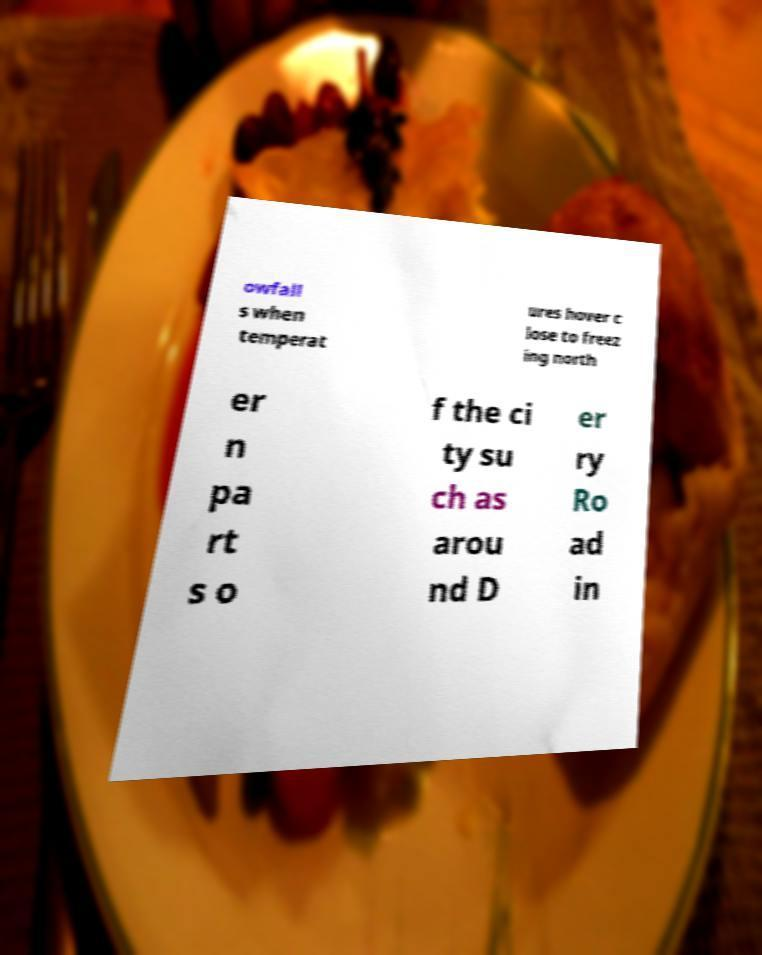Can you accurately transcribe the text from the provided image for me? owfall s when temperat ures hover c lose to freez ing north er n pa rt s o f the ci ty su ch as arou nd D er ry Ro ad in 